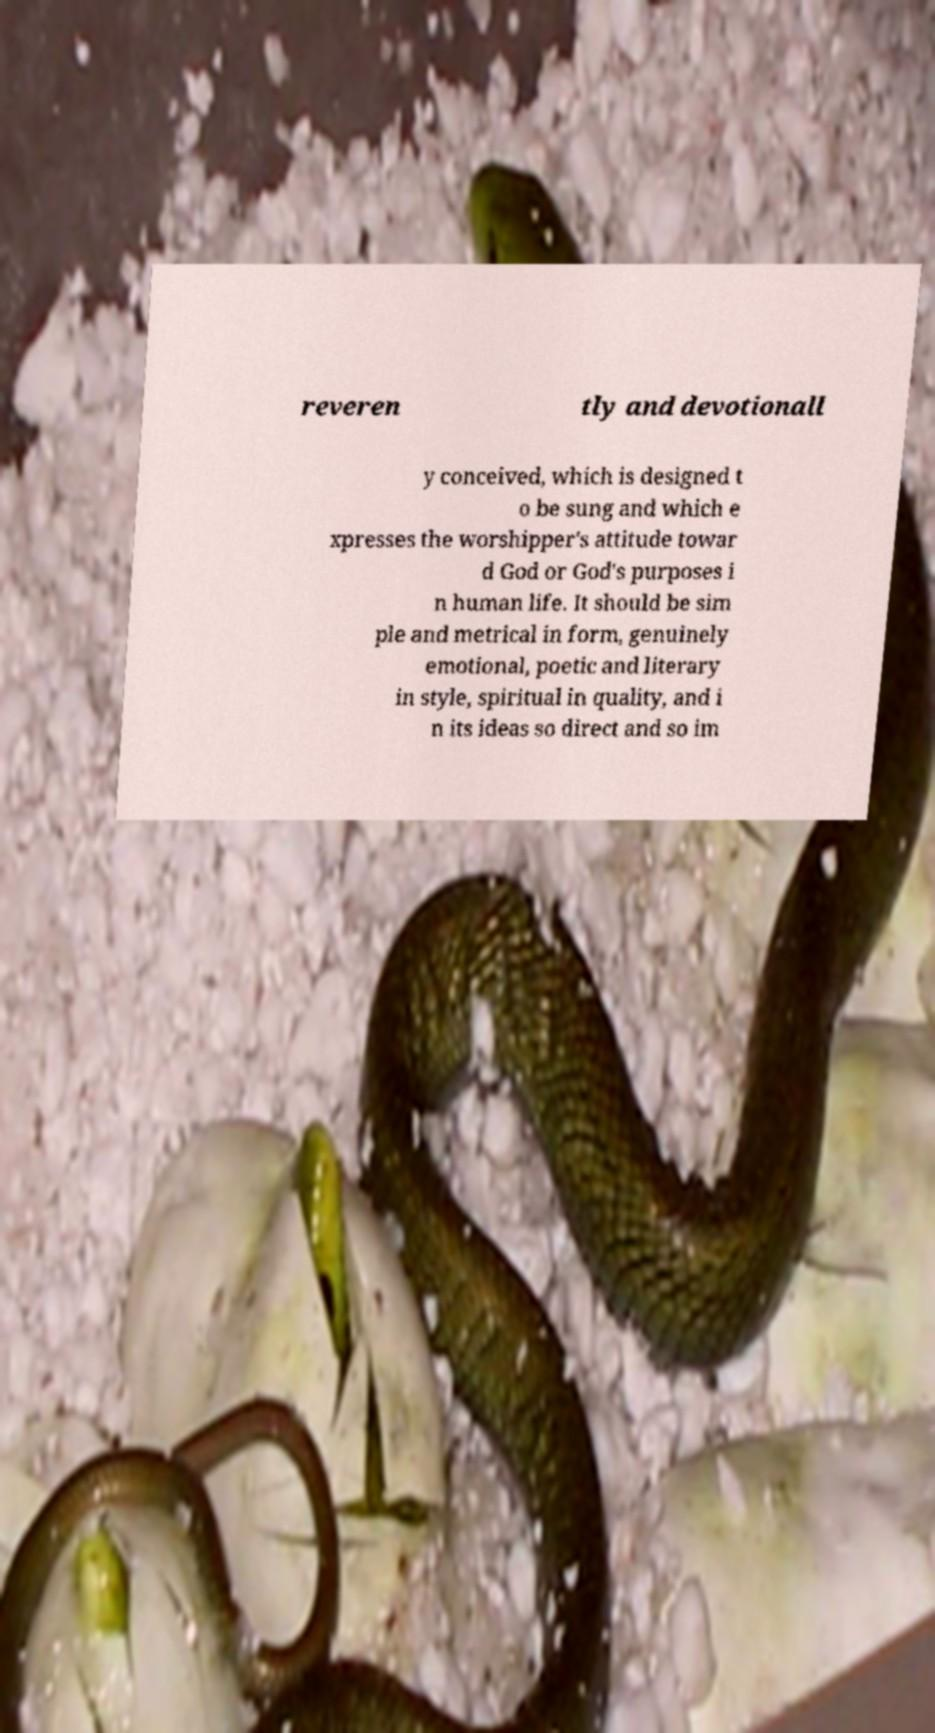Could you assist in decoding the text presented in this image and type it out clearly? reveren tly and devotionall y conceived, which is designed t o be sung and which e xpresses the worshipper's attitude towar d God or God's purposes i n human life. It should be sim ple and metrical in form, genuinely emotional, poetic and literary in style, spiritual in quality, and i n its ideas so direct and so im 